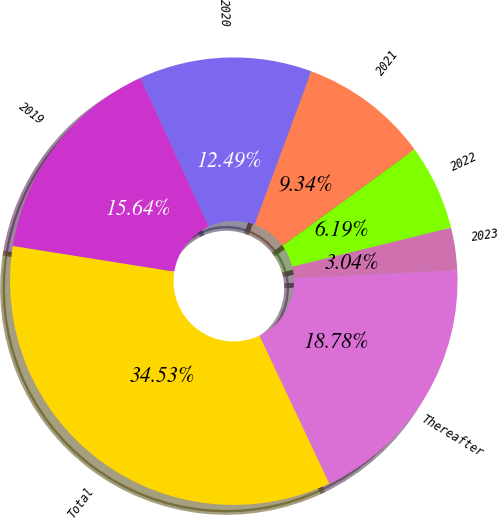Convert chart to OTSL. <chart><loc_0><loc_0><loc_500><loc_500><pie_chart><fcel>2019<fcel>2020<fcel>2021<fcel>2022<fcel>2023<fcel>Thereafter<fcel>Total<nl><fcel>15.64%<fcel>12.49%<fcel>9.34%<fcel>6.19%<fcel>3.04%<fcel>18.78%<fcel>34.53%<nl></chart> 